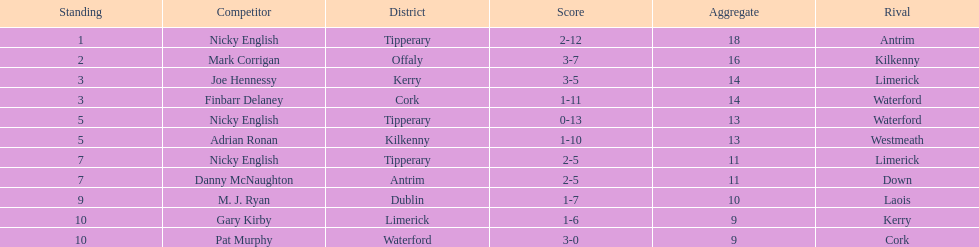If you added all the total's up, what would the number be? 138. 